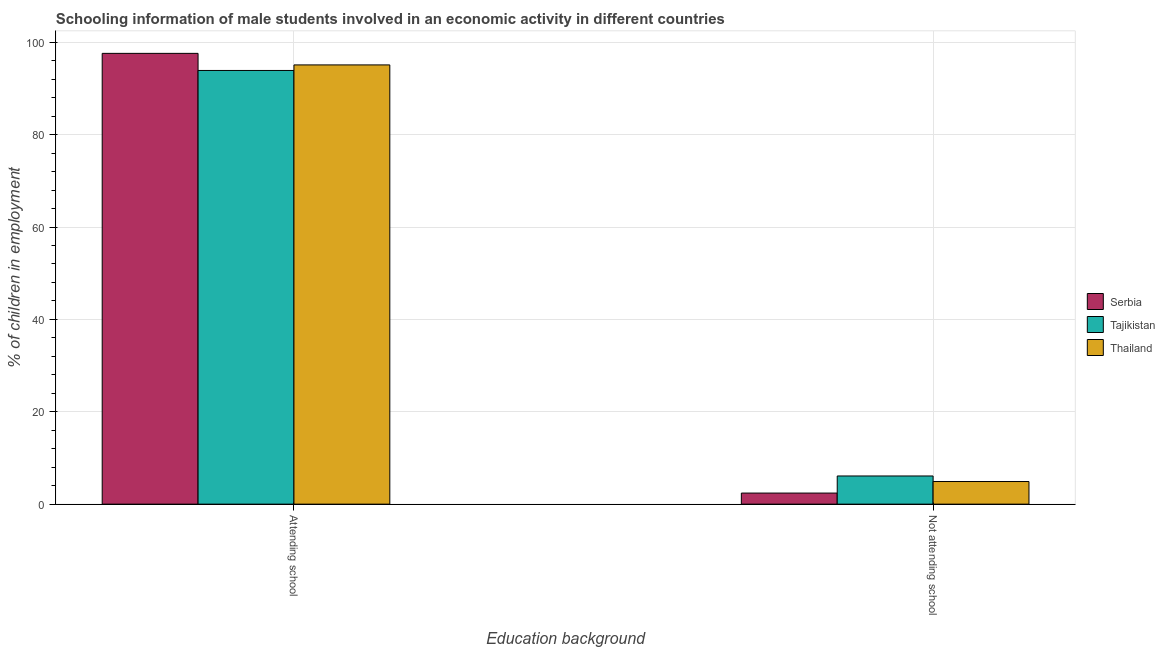How many different coloured bars are there?
Provide a short and direct response. 3. Are the number of bars per tick equal to the number of legend labels?
Your answer should be compact. Yes. Are the number of bars on each tick of the X-axis equal?
Your response must be concise. Yes. How many bars are there on the 2nd tick from the left?
Your response must be concise. 3. How many bars are there on the 1st tick from the right?
Your response must be concise. 3. What is the label of the 1st group of bars from the left?
Ensure brevity in your answer.  Attending school. In which country was the percentage of employed males who are attending school maximum?
Your answer should be very brief. Serbia. In which country was the percentage of employed males who are not attending school minimum?
Your response must be concise. Serbia. What is the difference between the percentage of employed males who are attending school in Thailand and that in Serbia?
Your answer should be compact. -2.5. What is the difference between the percentage of employed males who are not attending school in Serbia and the percentage of employed males who are attending school in Tajikistan?
Your answer should be compact. -91.5. What is the average percentage of employed males who are not attending school per country?
Your answer should be very brief. 4.47. What is the difference between the percentage of employed males who are not attending school and percentage of employed males who are attending school in Tajikistan?
Offer a very short reply. -87.8. What is the ratio of the percentage of employed males who are attending school in Thailand to that in Tajikistan?
Your answer should be very brief. 1.01. What does the 1st bar from the left in Attending school represents?
Ensure brevity in your answer.  Serbia. What does the 2nd bar from the right in Not attending school represents?
Offer a terse response. Tajikistan. How many bars are there?
Ensure brevity in your answer.  6. Are all the bars in the graph horizontal?
Provide a succinct answer. No. Are the values on the major ticks of Y-axis written in scientific E-notation?
Offer a very short reply. No. Does the graph contain any zero values?
Provide a succinct answer. No. Does the graph contain grids?
Your response must be concise. Yes. How are the legend labels stacked?
Give a very brief answer. Vertical. What is the title of the graph?
Your response must be concise. Schooling information of male students involved in an economic activity in different countries. Does "Monaco" appear as one of the legend labels in the graph?
Your response must be concise. No. What is the label or title of the X-axis?
Ensure brevity in your answer.  Education background. What is the label or title of the Y-axis?
Provide a short and direct response. % of children in employment. What is the % of children in employment of Serbia in Attending school?
Provide a short and direct response. 97.6. What is the % of children in employment in Tajikistan in Attending school?
Your answer should be compact. 93.9. What is the % of children in employment in Thailand in Attending school?
Give a very brief answer. 95.1. What is the % of children in employment in Serbia in Not attending school?
Provide a short and direct response. 2.4. What is the % of children in employment in Tajikistan in Not attending school?
Make the answer very short. 6.1. What is the % of children in employment in Thailand in Not attending school?
Give a very brief answer. 4.9. Across all Education background, what is the maximum % of children in employment of Serbia?
Give a very brief answer. 97.6. Across all Education background, what is the maximum % of children in employment of Tajikistan?
Ensure brevity in your answer.  93.9. Across all Education background, what is the maximum % of children in employment in Thailand?
Provide a short and direct response. 95.1. Across all Education background, what is the minimum % of children in employment in Tajikistan?
Keep it short and to the point. 6.1. What is the total % of children in employment in Tajikistan in the graph?
Ensure brevity in your answer.  100. What is the total % of children in employment of Thailand in the graph?
Keep it short and to the point. 100. What is the difference between the % of children in employment of Serbia in Attending school and that in Not attending school?
Keep it short and to the point. 95.2. What is the difference between the % of children in employment of Tajikistan in Attending school and that in Not attending school?
Provide a short and direct response. 87.8. What is the difference between the % of children in employment in Thailand in Attending school and that in Not attending school?
Ensure brevity in your answer.  90.2. What is the difference between the % of children in employment in Serbia in Attending school and the % of children in employment in Tajikistan in Not attending school?
Your response must be concise. 91.5. What is the difference between the % of children in employment of Serbia in Attending school and the % of children in employment of Thailand in Not attending school?
Ensure brevity in your answer.  92.7. What is the difference between the % of children in employment in Tajikistan in Attending school and the % of children in employment in Thailand in Not attending school?
Your answer should be compact. 89. What is the average % of children in employment of Thailand per Education background?
Your response must be concise. 50. What is the difference between the % of children in employment of Serbia and % of children in employment of Thailand in Attending school?
Keep it short and to the point. 2.5. What is the difference between the % of children in employment of Serbia and % of children in employment of Tajikistan in Not attending school?
Make the answer very short. -3.7. What is the difference between the % of children in employment of Serbia and % of children in employment of Thailand in Not attending school?
Provide a succinct answer. -2.5. What is the difference between the % of children in employment of Tajikistan and % of children in employment of Thailand in Not attending school?
Your response must be concise. 1.2. What is the ratio of the % of children in employment of Serbia in Attending school to that in Not attending school?
Offer a terse response. 40.67. What is the ratio of the % of children in employment of Tajikistan in Attending school to that in Not attending school?
Keep it short and to the point. 15.39. What is the ratio of the % of children in employment in Thailand in Attending school to that in Not attending school?
Provide a short and direct response. 19.41. What is the difference between the highest and the second highest % of children in employment in Serbia?
Your answer should be compact. 95.2. What is the difference between the highest and the second highest % of children in employment in Tajikistan?
Offer a very short reply. 87.8. What is the difference between the highest and the second highest % of children in employment of Thailand?
Your answer should be very brief. 90.2. What is the difference between the highest and the lowest % of children in employment of Serbia?
Offer a very short reply. 95.2. What is the difference between the highest and the lowest % of children in employment of Tajikistan?
Your response must be concise. 87.8. What is the difference between the highest and the lowest % of children in employment in Thailand?
Your answer should be compact. 90.2. 